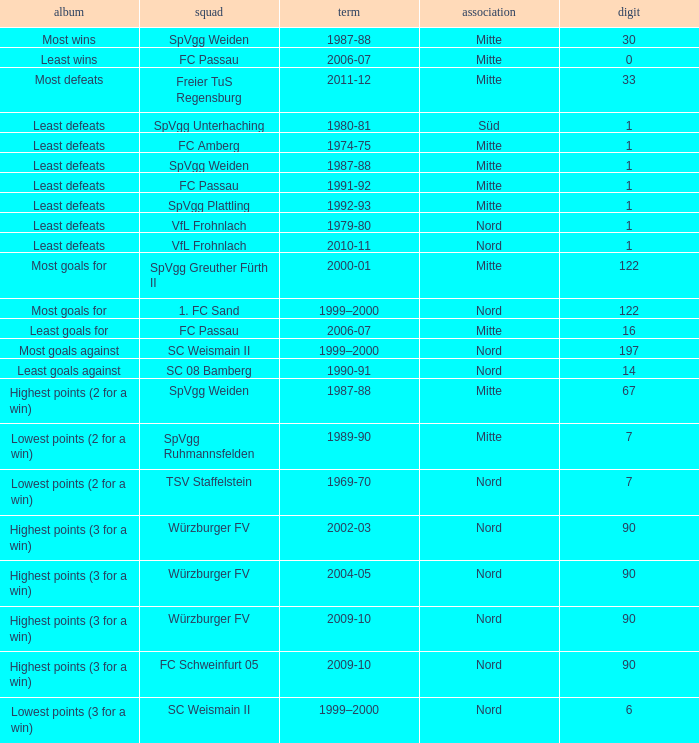What season has a number less than 90, Mitte as the league and spvgg ruhmannsfelden as the team? 1989-90. 